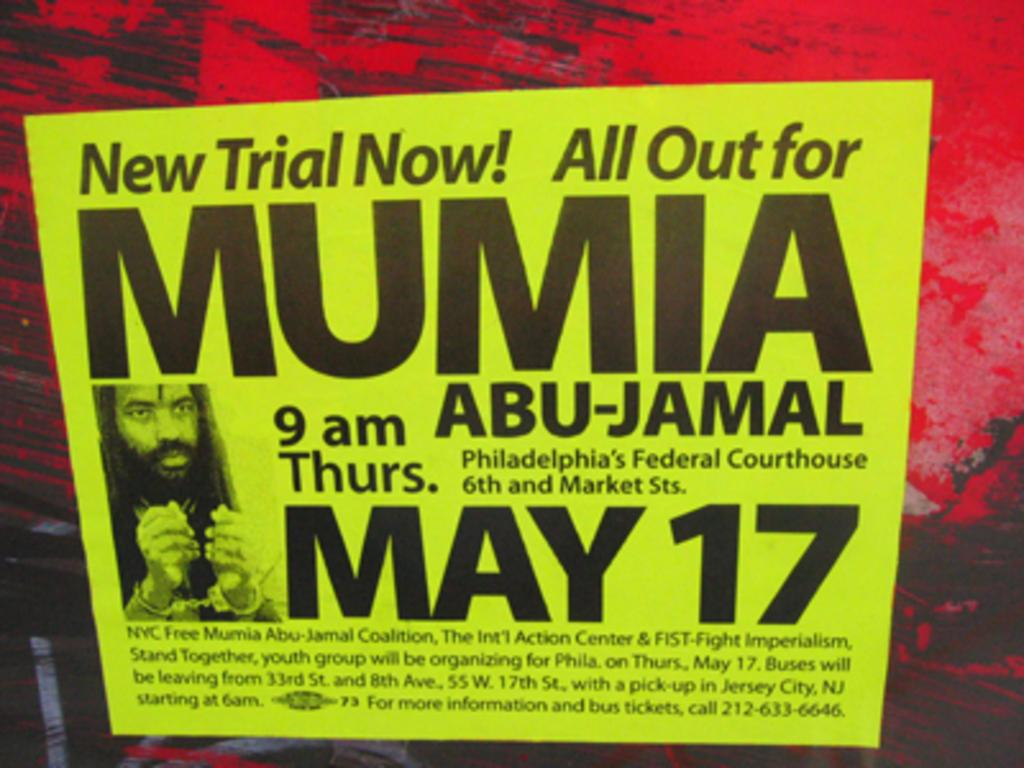<image>
Relay a brief, clear account of the picture shown. Poster advertising a free trial for MUMIA on May 17th. 